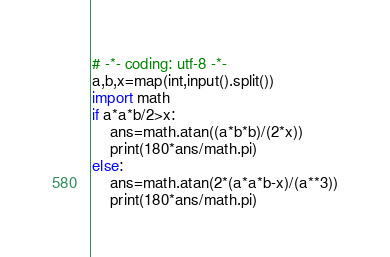<code> <loc_0><loc_0><loc_500><loc_500><_Python_># -*- coding: utf-8 -*-
a,b,x=map(int,input().split())
import math
if a*a*b/2>x:
    ans=math.atan((a*b*b)/(2*x))
    print(180*ans/math.pi)
else:
    ans=math.atan(2*(a*a*b-x)/(a**3))
    print(180*ans/math.pi)</code> 